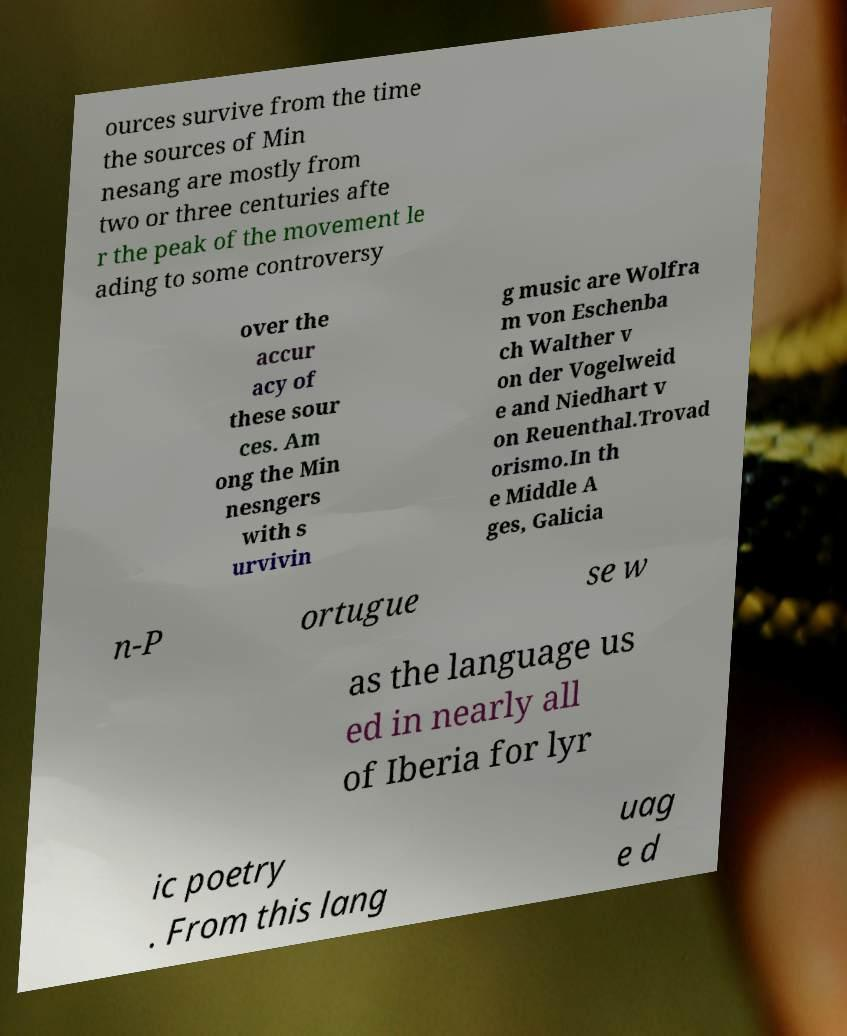There's text embedded in this image that I need extracted. Can you transcribe it verbatim? ources survive from the time the sources of Min nesang are mostly from two or three centuries afte r the peak of the movement le ading to some controversy over the accur acy of these sour ces. Am ong the Min nesngers with s urvivin g music are Wolfra m von Eschenba ch Walther v on der Vogelweid e and Niedhart v on Reuenthal.Trovad orismo.In th e Middle A ges, Galicia n-P ortugue se w as the language us ed in nearly all of Iberia for lyr ic poetry . From this lang uag e d 